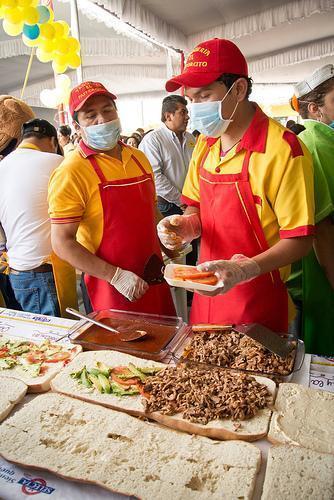How many people are wearing orange and red uniforms?
Give a very brief answer. 2. How many people are wearing lime green, visibly?
Give a very brief answer. 1. 